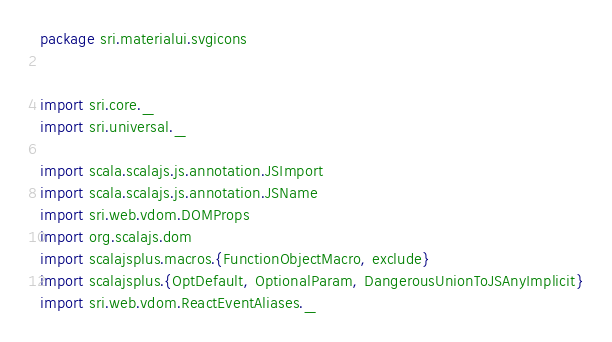<code> <loc_0><loc_0><loc_500><loc_500><_Scala_>package sri.materialui.svgicons


import sri.core._
import sri.universal._

import scala.scalajs.js.annotation.JSImport
import scala.scalajs.js.annotation.JSName
import sri.web.vdom.DOMProps
import org.scalajs.dom
import scalajsplus.macros.{FunctionObjectMacro, exclude}
import scalajsplus.{OptDefault, OptionalParam, DangerousUnionToJSAnyImplicit}
import sri.web.vdom.ReactEventAliases._
</code> 